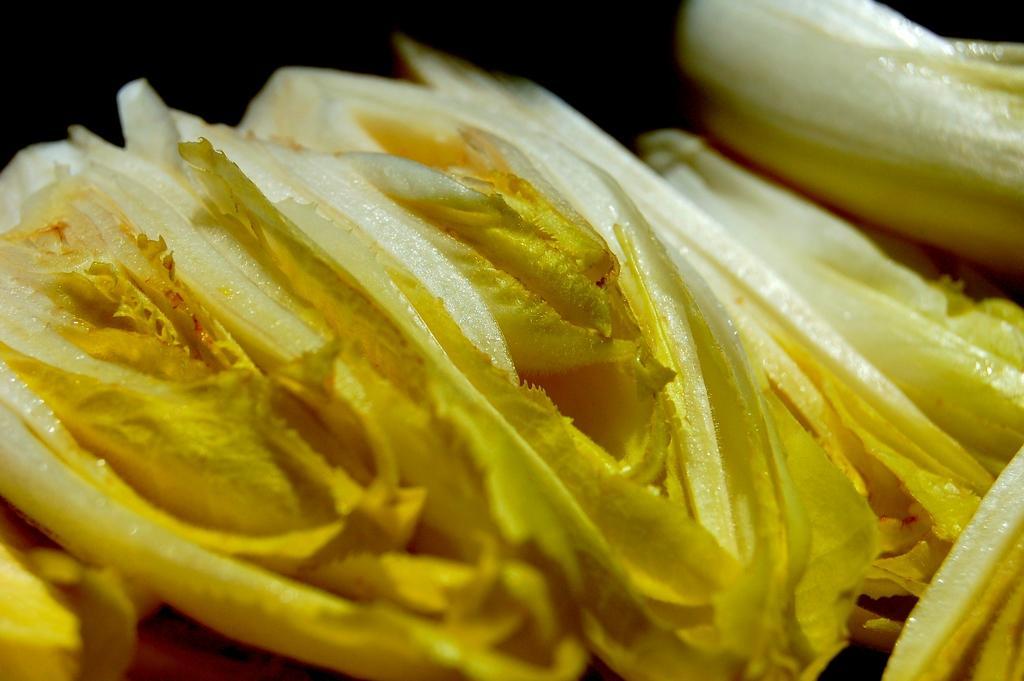Can you describe this image briefly? In this image we can see some objects, which looks like food items, and the background is dark. 